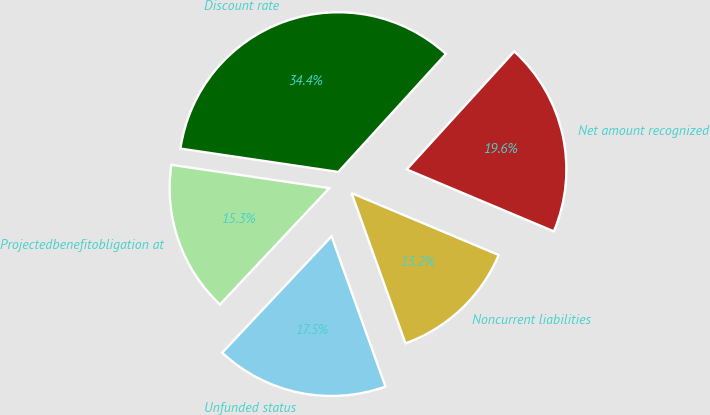Convert chart to OTSL. <chart><loc_0><loc_0><loc_500><loc_500><pie_chart><fcel>Projectedbenefitobligation at<fcel>Unfunded status<fcel>Noncurrent liabilities<fcel>Net amount recognized<fcel>Discount rate<nl><fcel>15.33%<fcel>17.49%<fcel>13.17%<fcel>19.58%<fcel>34.43%<nl></chart> 